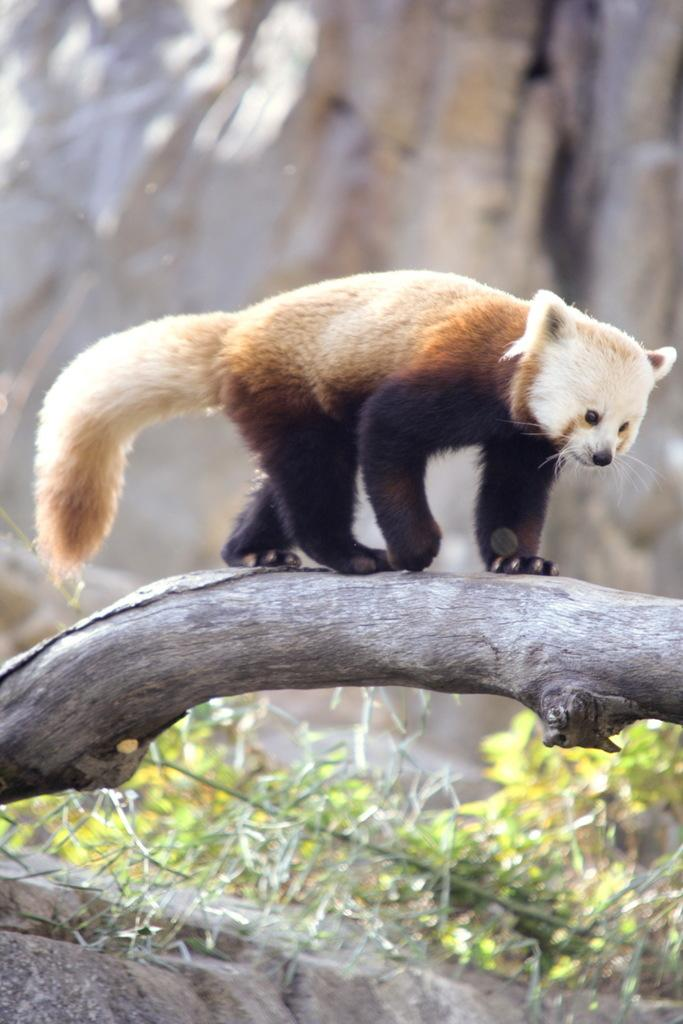What type of animal is in the image? The type of animal cannot be determined from the provided facts. What is the animal doing in the image? The animal is walking on a wooden object. How would you describe the background of the image? The background of the image is blurred. Are there any plants visible in the image? Yes, there are plants in the image. What type of music is being played in the background of the image? There is no information about music being played in the image. How much grain is visible in the image? There is no mention of grain in the image. 